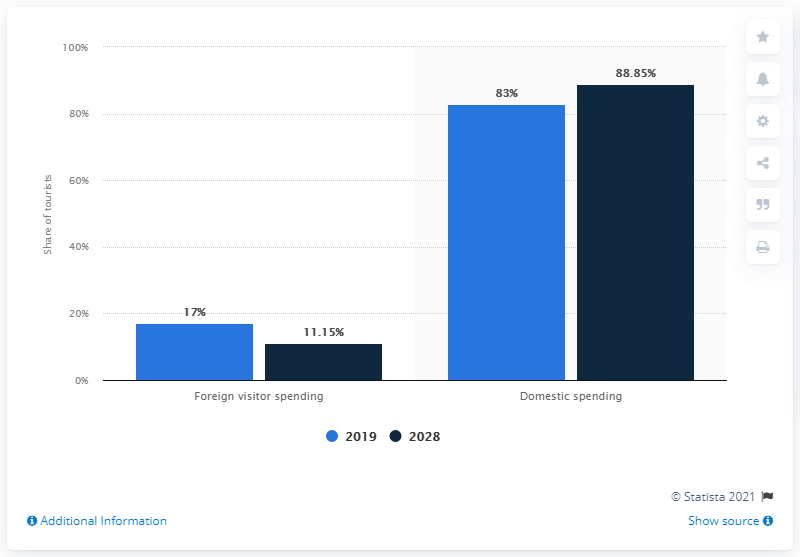Give some essential details in this illustration. By 2028, the domestic spending share was expected to decrease. The average of 2019, as indicated by two blue bars, is 50. In 2028, the Domestic bar with the highest value is 2019. 